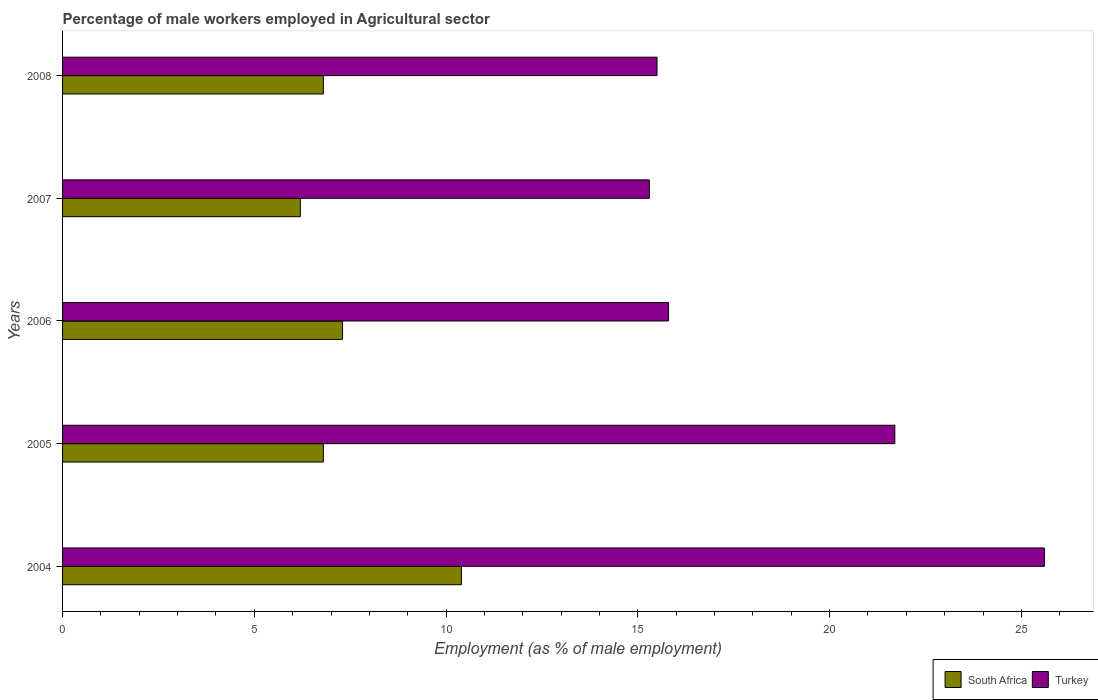How many groups of bars are there?
Provide a succinct answer. 5. Are the number of bars per tick equal to the number of legend labels?
Ensure brevity in your answer.  Yes. Are the number of bars on each tick of the Y-axis equal?
Make the answer very short. Yes. How many bars are there on the 5th tick from the bottom?
Offer a terse response. 2. What is the label of the 3rd group of bars from the top?
Provide a succinct answer. 2006. What is the percentage of male workers employed in Agricultural sector in South Africa in 2008?
Offer a terse response. 6.8. Across all years, what is the maximum percentage of male workers employed in Agricultural sector in Turkey?
Your answer should be very brief. 25.6. Across all years, what is the minimum percentage of male workers employed in Agricultural sector in Turkey?
Provide a succinct answer. 15.3. What is the total percentage of male workers employed in Agricultural sector in Turkey in the graph?
Keep it short and to the point. 93.9. What is the difference between the percentage of male workers employed in Agricultural sector in Turkey in 2005 and that in 2007?
Give a very brief answer. 6.4. What is the difference between the percentage of male workers employed in Agricultural sector in Turkey in 2008 and the percentage of male workers employed in Agricultural sector in South Africa in 2007?
Keep it short and to the point. 9.3. What is the average percentage of male workers employed in Agricultural sector in Turkey per year?
Your answer should be compact. 18.78. In the year 2006, what is the difference between the percentage of male workers employed in Agricultural sector in Turkey and percentage of male workers employed in Agricultural sector in South Africa?
Your response must be concise. 8.5. In how many years, is the percentage of male workers employed in Agricultural sector in Turkey greater than 7 %?
Your answer should be very brief. 5. What is the ratio of the percentage of male workers employed in Agricultural sector in Turkey in 2005 to that in 2008?
Give a very brief answer. 1.4. What is the difference between the highest and the second highest percentage of male workers employed in Agricultural sector in Turkey?
Keep it short and to the point. 3.9. What is the difference between the highest and the lowest percentage of male workers employed in Agricultural sector in South Africa?
Your answer should be compact. 4.2. In how many years, is the percentage of male workers employed in Agricultural sector in South Africa greater than the average percentage of male workers employed in Agricultural sector in South Africa taken over all years?
Make the answer very short. 1. What does the 2nd bar from the top in 2004 represents?
Ensure brevity in your answer.  South Africa. What does the 2nd bar from the bottom in 2004 represents?
Provide a succinct answer. Turkey. What is the difference between two consecutive major ticks on the X-axis?
Provide a short and direct response. 5. Does the graph contain grids?
Give a very brief answer. No. How many legend labels are there?
Provide a succinct answer. 2. What is the title of the graph?
Keep it short and to the point. Percentage of male workers employed in Agricultural sector. What is the label or title of the X-axis?
Offer a terse response. Employment (as % of male employment). What is the Employment (as % of male employment) in South Africa in 2004?
Your answer should be compact. 10.4. What is the Employment (as % of male employment) of Turkey in 2004?
Your answer should be compact. 25.6. What is the Employment (as % of male employment) of South Africa in 2005?
Your response must be concise. 6.8. What is the Employment (as % of male employment) in Turkey in 2005?
Give a very brief answer. 21.7. What is the Employment (as % of male employment) of South Africa in 2006?
Offer a very short reply. 7.3. What is the Employment (as % of male employment) in Turkey in 2006?
Your answer should be compact. 15.8. What is the Employment (as % of male employment) in South Africa in 2007?
Provide a short and direct response. 6.2. What is the Employment (as % of male employment) of Turkey in 2007?
Give a very brief answer. 15.3. What is the Employment (as % of male employment) in South Africa in 2008?
Keep it short and to the point. 6.8. Across all years, what is the maximum Employment (as % of male employment) in South Africa?
Your response must be concise. 10.4. Across all years, what is the maximum Employment (as % of male employment) in Turkey?
Provide a short and direct response. 25.6. Across all years, what is the minimum Employment (as % of male employment) of South Africa?
Offer a very short reply. 6.2. Across all years, what is the minimum Employment (as % of male employment) in Turkey?
Offer a terse response. 15.3. What is the total Employment (as % of male employment) of South Africa in the graph?
Provide a succinct answer. 37.5. What is the total Employment (as % of male employment) of Turkey in the graph?
Provide a short and direct response. 93.9. What is the difference between the Employment (as % of male employment) in South Africa in 2004 and that in 2005?
Provide a succinct answer. 3.6. What is the difference between the Employment (as % of male employment) of South Africa in 2004 and that in 2007?
Ensure brevity in your answer.  4.2. What is the difference between the Employment (as % of male employment) in Turkey in 2004 and that in 2007?
Provide a short and direct response. 10.3. What is the difference between the Employment (as % of male employment) in South Africa in 2004 and that in 2008?
Make the answer very short. 3.6. What is the difference between the Employment (as % of male employment) in South Africa in 2005 and that in 2006?
Provide a succinct answer. -0.5. What is the difference between the Employment (as % of male employment) in Turkey in 2005 and that in 2006?
Provide a succinct answer. 5.9. What is the difference between the Employment (as % of male employment) of Turkey in 2005 and that in 2008?
Your answer should be very brief. 6.2. What is the difference between the Employment (as % of male employment) in South Africa in 2006 and that in 2007?
Provide a short and direct response. 1.1. What is the difference between the Employment (as % of male employment) in Turkey in 2007 and that in 2008?
Give a very brief answer. -0.2. What is the difference between the Employment (as % of male employment) in South Africa in 2004 and the Employment (as % of male employment) in Turkey in 2005?
Your answer should be compact. -11.3. What is the difference between the Employment (as % of male employment) of South Africa in 2005 and the Employment (as % of male employment) of Turkey in 2008?
Provide a short and direct response. -8.7. What is the difference between the Employment (as % of male employment) in South Africa in 2006 and the Employment (as % of male employment) in Turkey in 2008?
Keep it short and to the point. -8.2. What is the average Employment (as % of male employment) in Turkey per year?
Provide a short and direct response. 18.78. In the year 2004, what is the difference between the Employment (as % of male employment) in South Africa and Employment (as % of male employment) in Turkey?
Ensure brevity in your answer.  -15.2. In the year 2005, what is the difference between the Employment (as % of male employment) in South Africa and Employment (as % of male employment) in Turkey?
Ensure brevity in your answer.  -14.9. In the year 2007, what is the difference between the Employment (as % of male employment) in South Africa and Employment (as % of male employment) in Turkey?
Provide a succinct answer. -9.1. What is the ratio of the Employment (as % of male employment) of South Africa in 2004 to that in 2005?
Ensure brevity in your answer.  1.53. What is the ratio of the Employment (as % of male employment) of Turkey in 2004 to that in 2005?
Provide a succinct answer. 1.18. What is the ratio of the Employment (as % of male employment) of South Africa in 2004 to that in 2006?
Ensure brevity in your answer.  1.42. What is the ratio of the Employment (as % of male employment) in Turkey in 2004 to that in 2006?
Your answer should be very brief. 1.62. What is the ratio of the Employment (as % of male employment) of South Africa in 2004 to that in 2007?
Provide a short and direct response. 1.68. What is the ratio of the Employment (as % of male employment) of Turkey in 2004 to that in 2007?
Ensure brevity in your answer.  1.67. What is the ratio of the Employment (as % of male employment) of South Africa in 2004 to that in 2008?
Your answer should be very brief. 1.53. What is the ratio of the Employment (as % of male employment) in Turkey in 2004 to that in 2008?
Give a very brief answer. 1.65. What is the ratio of the Employment (as % of male employment) of South Africa in 2005 to that in 2006?
Provide a short and direct response. 0.93. What is the ratio of the Employment (as % of male employment) in Turkey in 2005 to that in 2006?
Offer a very short reply. 1.37. What is the ratio of the Employment (as % of male employment) of South Africa in 2005 to that in 2007?
Make the answer very short. 1.1. What is the ratio of the Employment (as % of male employment) of Turkey in 2005 to that in 2007?
Ensure brevity in your answer.  1.42. What is the ratio of the Employment (as % of male employment) of South Africa in 2006 to that in 2007?
Ensure brevity in your answer.  1.18. What is the ratio of the Employment (as % of male employment) of Turkey in 2006 to that in 2007?
Provide a short and direct response. 1.03. What is the ratio of the Employment (as % of male employment) of South Africa in 2006 to that in 2008?
Provide a short and direct response. 1.07. What is the ratio of the Employment (as % of male employment) of Turkey in 2006 to that in 2008?
Give a very brief answer. 1.02. What is the ratio of the Employment (as % of male employment) of South Africa in 2007 to that in 2008?
Make the answer very short. 0.91. What is the ratio of the Employment (as % of male employment) of Turkey in 2007 to that in 2008?
Offer a very short reply. 0.99. What is the difference between the highest and the second highest Employment (as % of male employment) in South Africa?
Your response must be concise. 3.1. What is the difference between the highest and the second highest Employment (as % of male employment) in Turkey?
Provide a short and direct response. 3.9. What is the difference between the highest and the lowest Employment (as % of male employment) of Turkey?
Give a very brief answer. 10.3. 